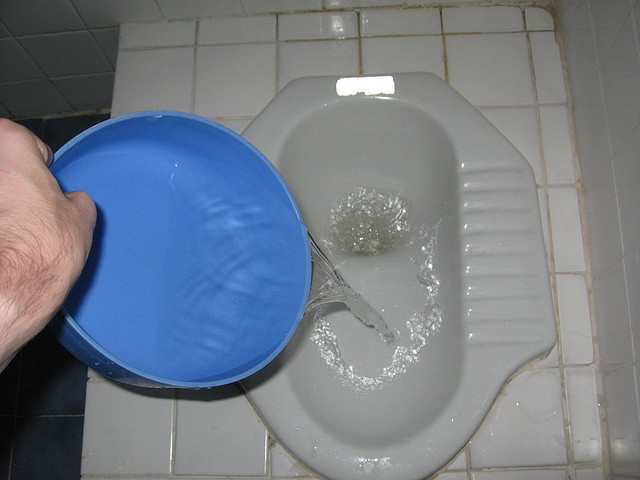Describe the objects in this image and their specific colors. I can see toilet in black, darkgray, gray, and white tones, bowl in black, gray, and blue tones, and people in black, lightpink, gray, darkgray, and salmon tones in this image. 